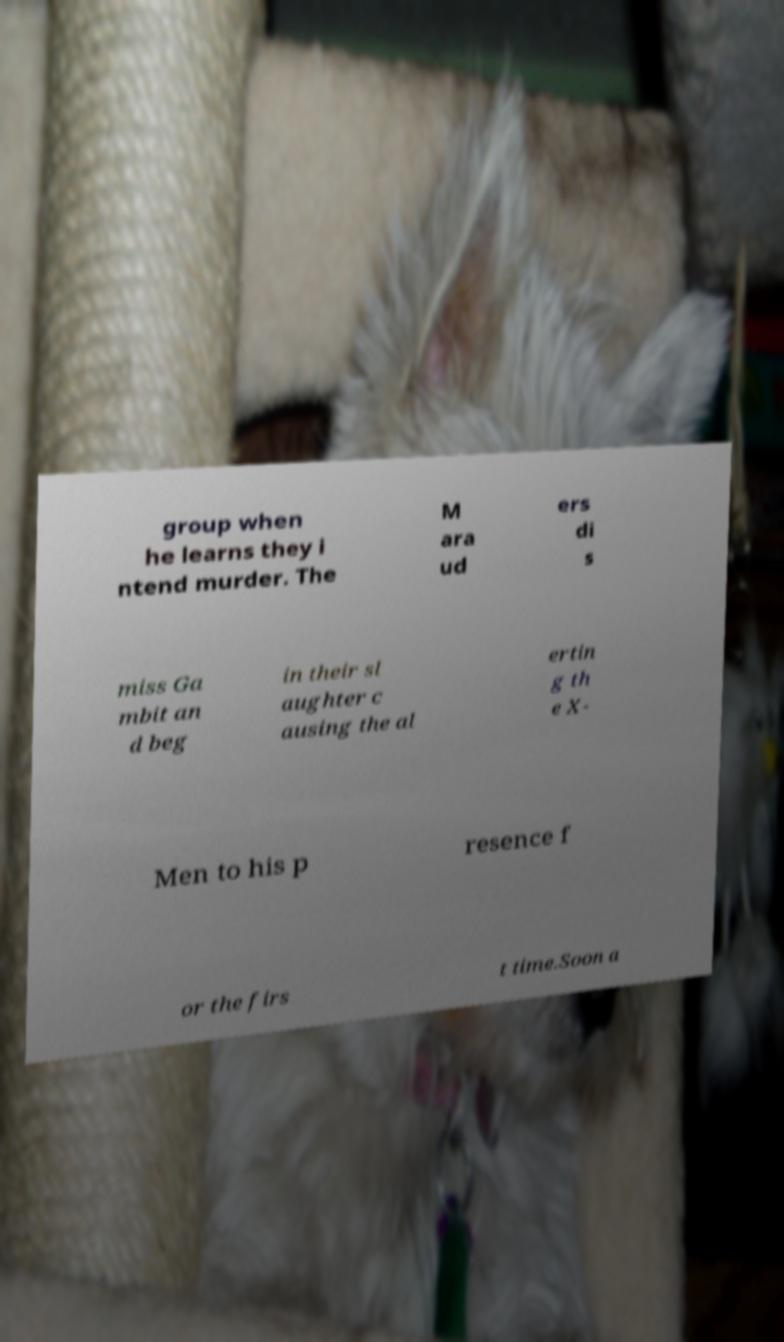Please identify and transcribe the text found in this image. group when he learns they i ntend murder. The M ara ud ers di s miss Ga mbit an d beg in their sl aughter c ausing the al ertin g th e X- Men to his p resence f or the firs t time.Soon a 